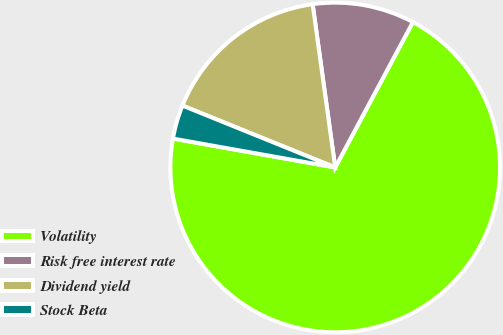Convert chart. <chart><loc_0><loc_0><loc_500><loc_500><pie_chart><fcel>Volatility<fcel>Risk free interest rate<fcel>Dividend yield<fcel>Stock Beta<nl><fcel>69.99%<fcel>10.0%<fcel>16.69%<fcel>3.32%<nl></chart> 